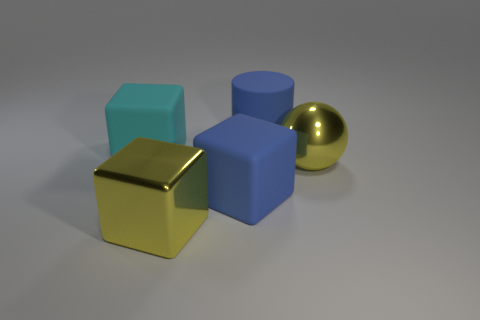Add 2 large metal cubes. How many objects exist? 7 Subtract all red balls. Subtract all cyan cylinders. How many balls are left? 1 Subtract all spheres. How many objects are left? 4 Subtract 1 blue cylinders. How many objects are left? 4 Subtract all small matte spheres. Subtract all large blue rubber blocks. How many objects are left? 4 Add 3 blue matte cubes. How many blue matte cubes are left? 4 Add 3 tiny brown things. How many tiny brown things exist? 3 